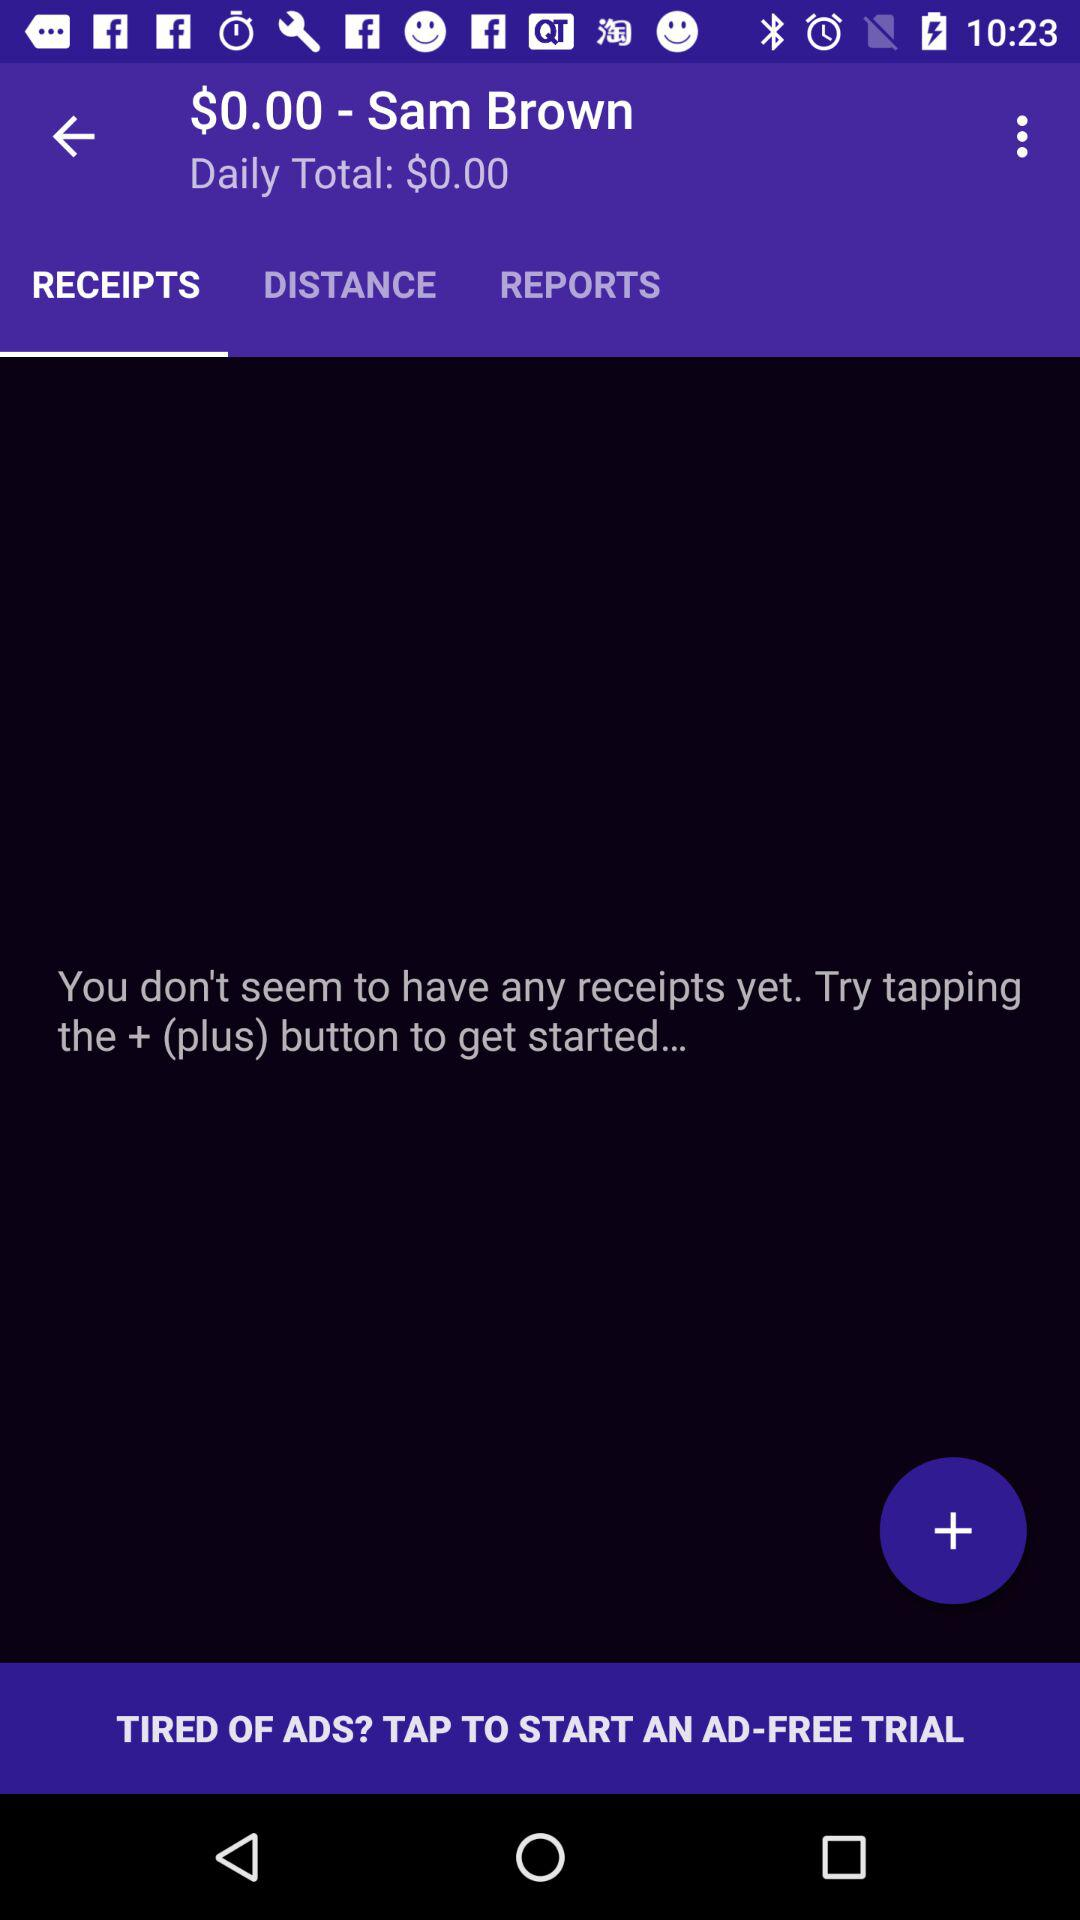How much is Sam Brown's daily total?
Answer the question using a single word or phrase. $0.00 